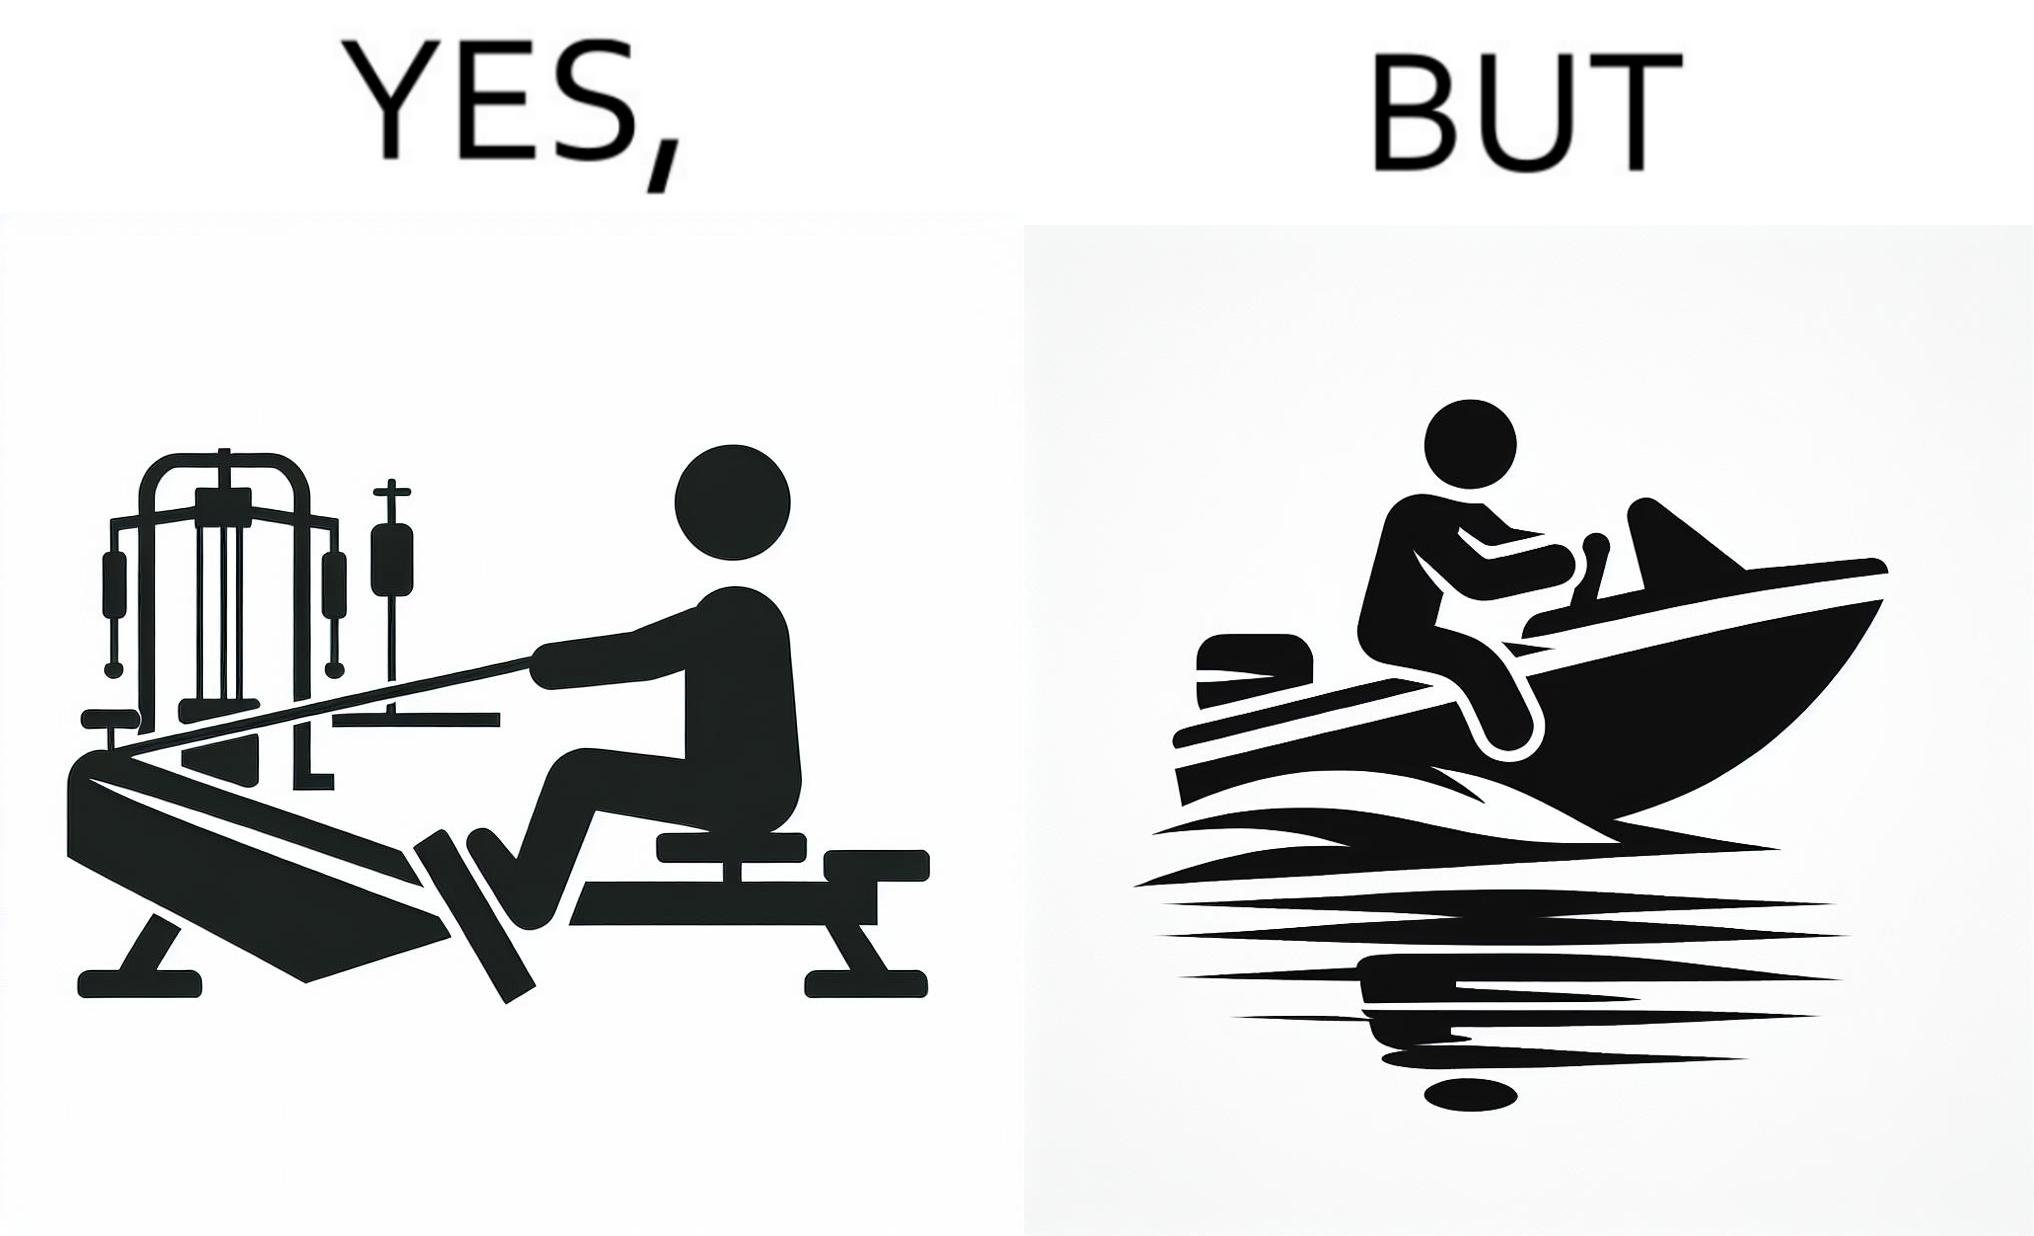What is shown in the left half versus the right half of this image? In the left part of the image: a person doing rowing exercise in gym In the right part of the image: a person riding a motorboat 